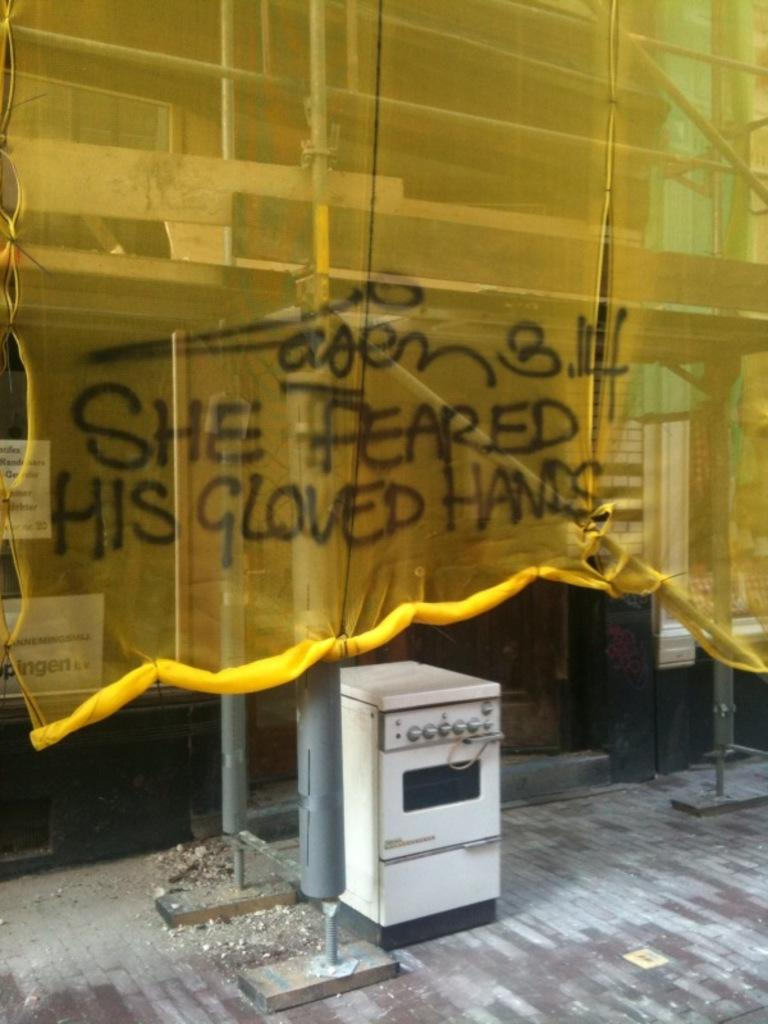<image>
Share a concise interpretation of the image provided. A yellow screen over scaffolding has graffiti that says "she feared his gloved hands". 